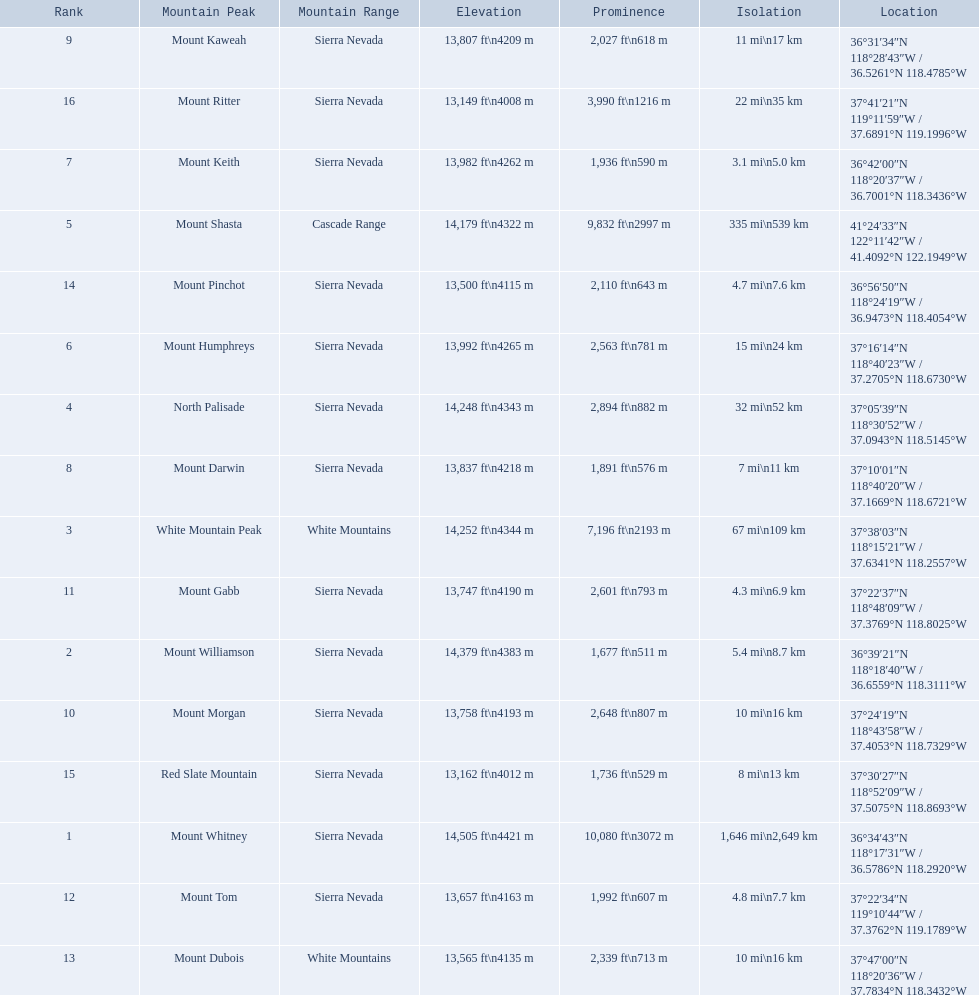What are the peaks in california? Mount Whitney, Mount Williamson, White Mountain Peak, North Palisade, Mount Shasta, Mount Humphreys, Mount Keith, Mount Darwin, Mount Kaweah, Mount Morgan, Mount Gabb, Mount Tom, Mount Dubois, Mount Pinchot, Red Slate Mountain, Mount Ritter. What are the peaks in sierra nevada, california? Mount Whitney, Mount Williamson, North Palisade, Mount Humphreys, Mount Keith, Mount Darwin, Mount Kaweah, Mount Morgan, Mount Gabb, Mount Tom, Mount Pinchot, Red Slate Mountain, Mount Ritter. What are the heights of the peaks in sierra nevada? 14,505 ft\n4421 m, 14,379 ft\n4383 m, 14,248 ft\n4343 m, 13,992 ft\n4265 m, 13,982 ft\n4262 m, 13,837 ft\n4218 m, 13,807 ft\n4209 m, 13,758 ft\n4193 m, 13,747 ft\n4190 m, 13,657 ft\n4163 m, 13,500 ft\n4115 m, 13,162 ft\n4012 m, 13,149 ft\n4008 m. Which is the highest? Mount Whitney. 